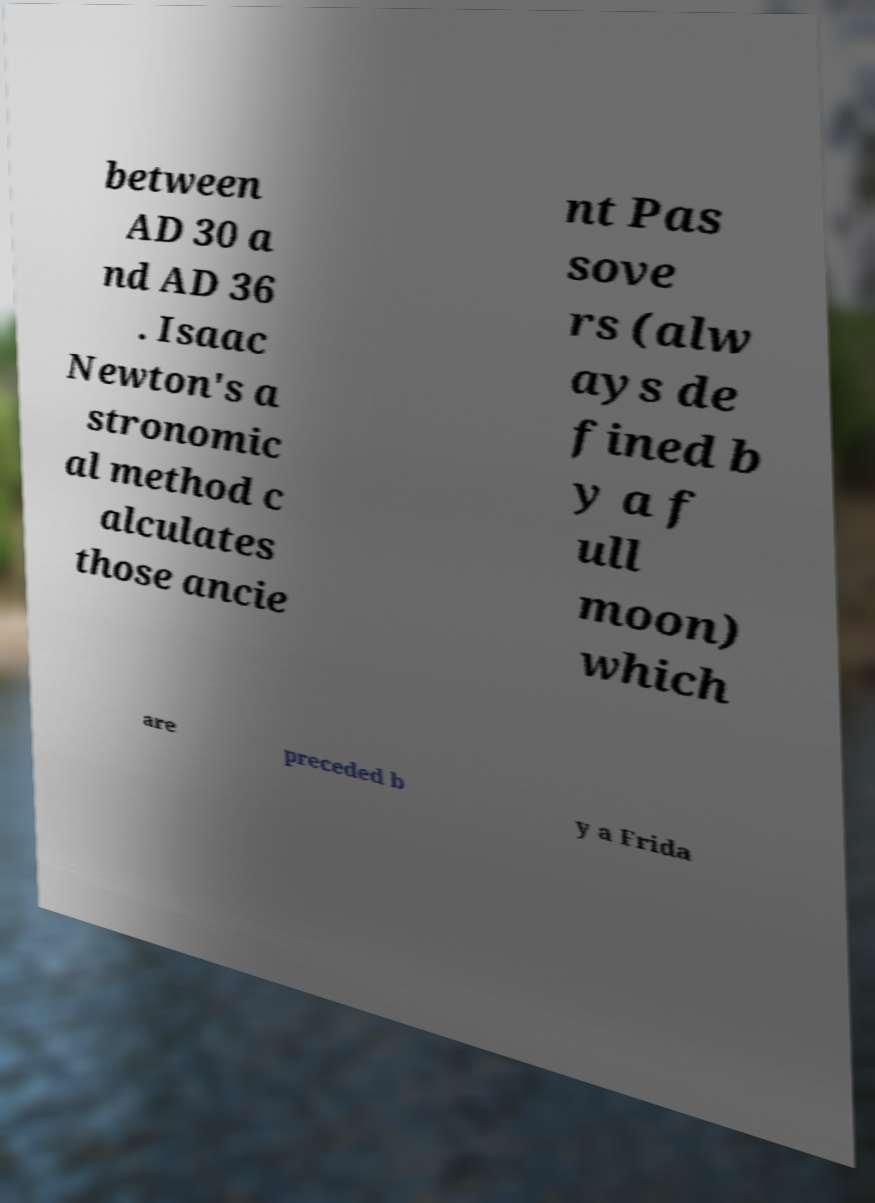For documentation purposes, I need the text within this image transcribed. Could you provide that? between AD 30 a nd AD 36 . Isaac Newton's a stronomic al method c alculates those ancie nt Pas sove rs (alw ays de fined b y a f ull moon) which are preceded b y a Frida 